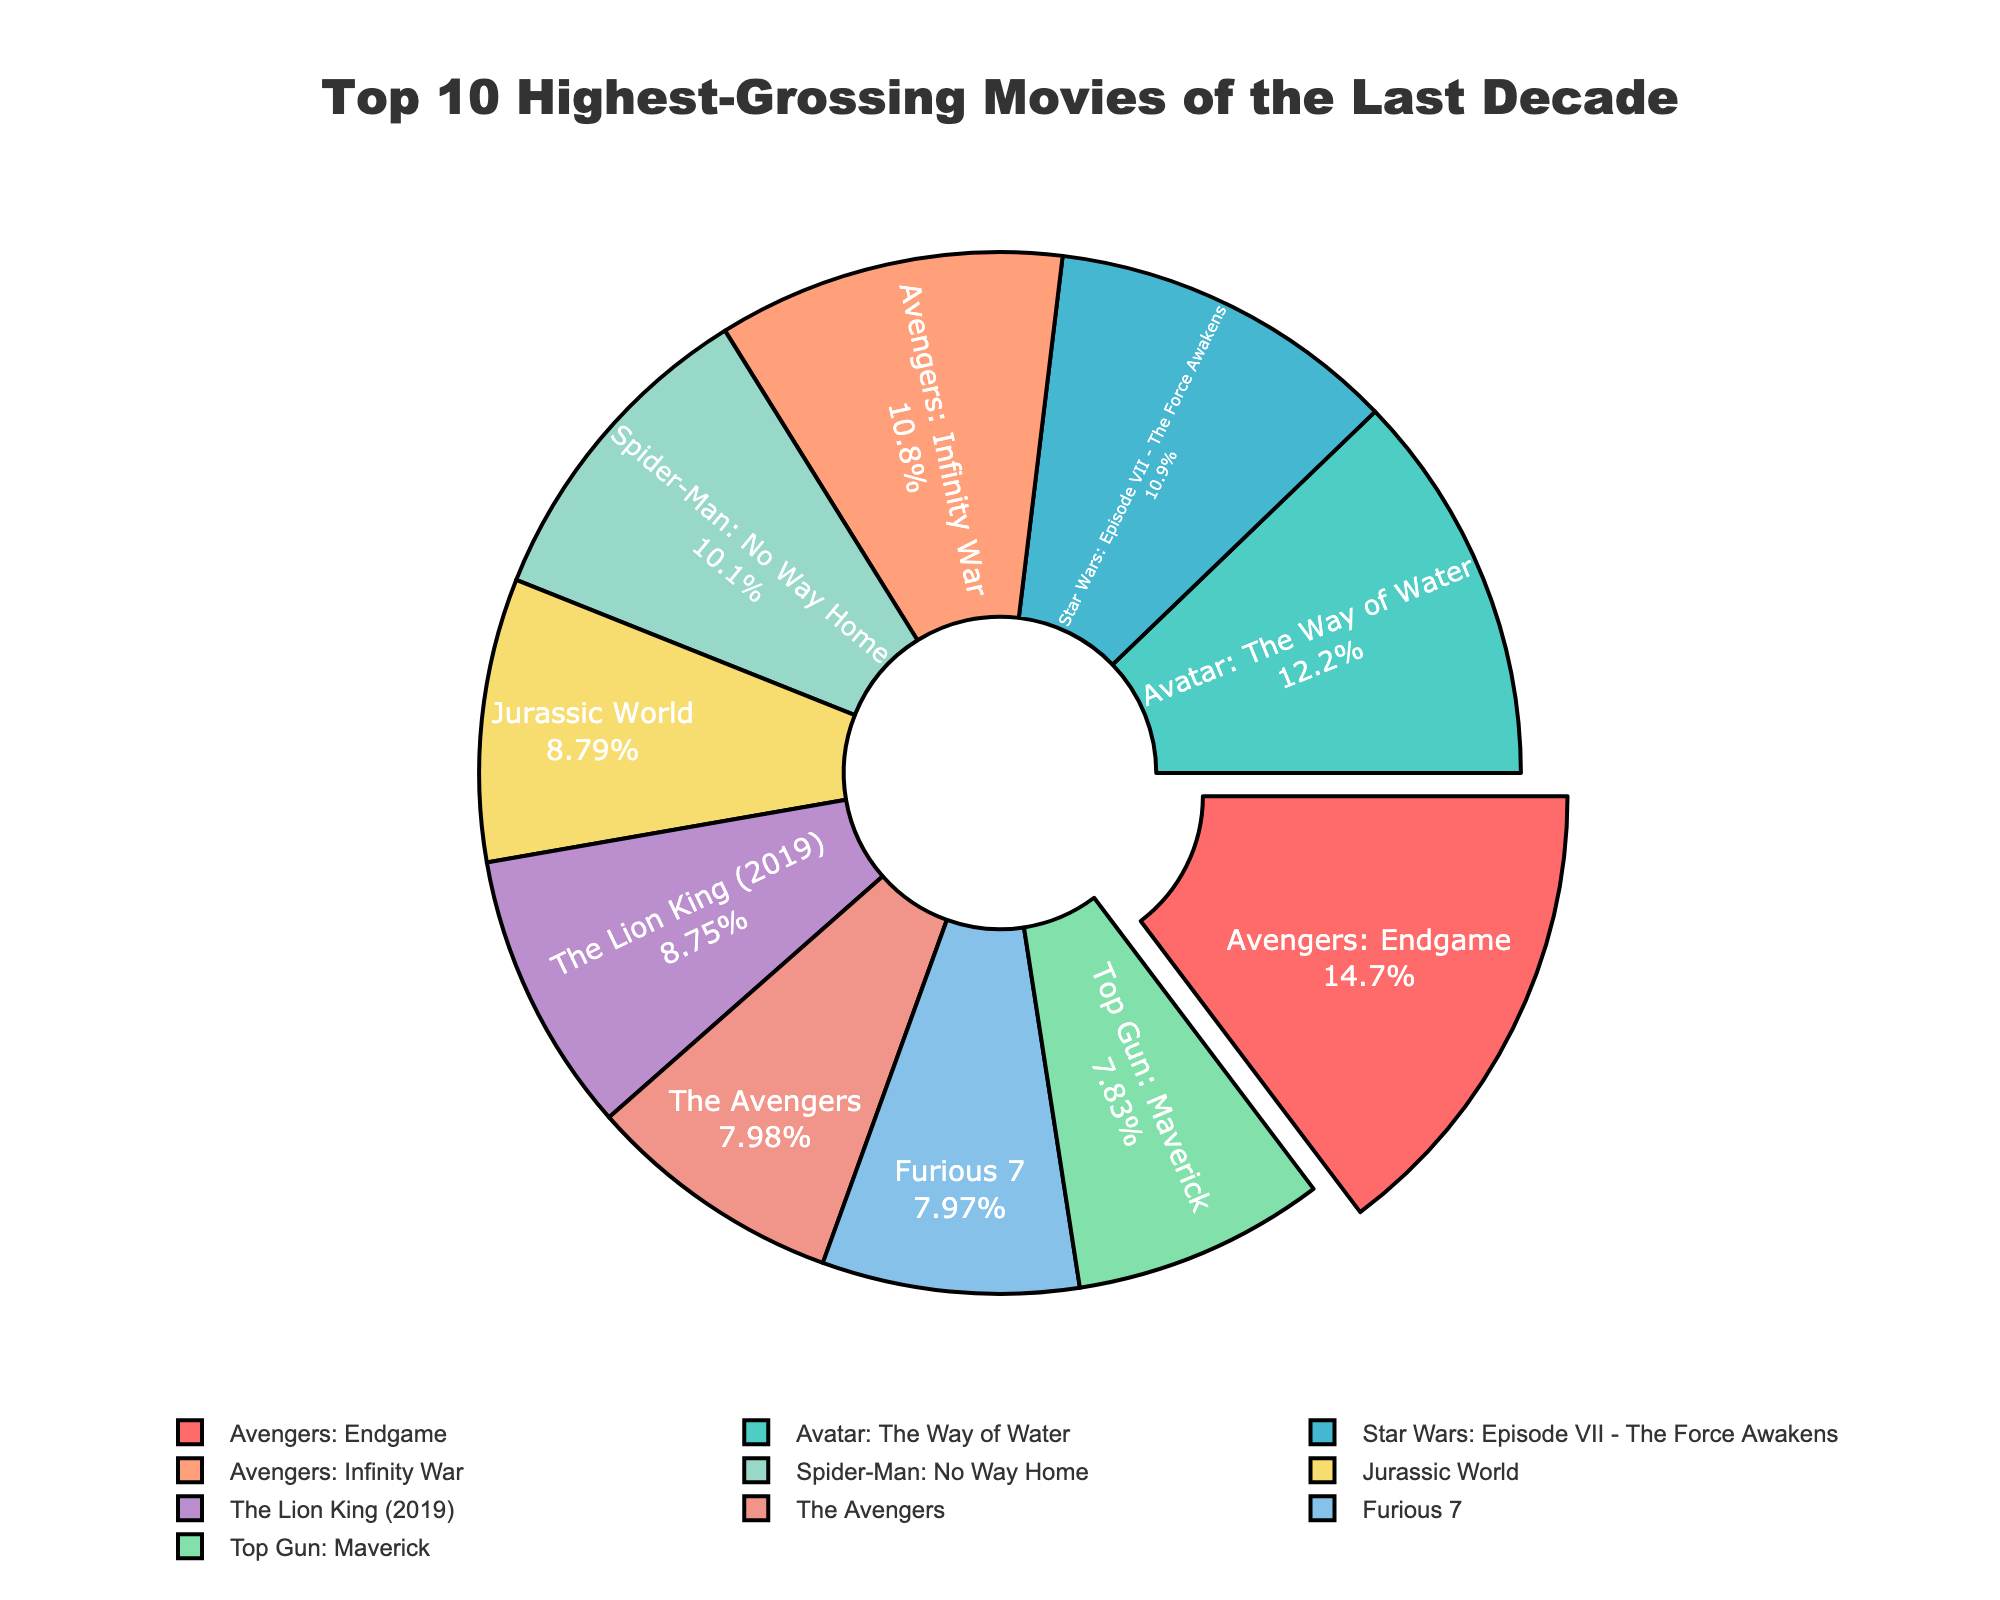Which movie had the highest box office revenue? The movie with the highest box office revenue will have the largest section in the pie chart. In this case, the largest section is labeled "Avengers: Endgame."
Answer: Avengers: Endgame Which movie earned more revenue, 'Furious 7' or 'Top Gun: Maverick'? Identify the sections representing 'Furious 7' and 'Top Gun: Maverick' and compare their size and percentage. 'Furious 7' and 'Top Gun: Maverick' have similar segment sizes, but 'Furious 7' has a slightly larger share.
Answer: Furious 7 What is the combined box office revenue of 'Avengers: Endgame' and 'Avatar: The Way of Water'? Find the values associated with these movies from the slices labeled accordingly, then add their revenues: 2.798 billion (Avengers: Endgame) + 2.32 billion (Avatar: The Way of Water) = 5.118 billion.
Answer: 5.118 billion What's the difference in revenue between 'Star Wars: Episode VII - The Force Awakens' and 'The Lion King (2019)'? Calculate the revenue difference: 2.068 billion (Star Wars: Episode VII - The Force Awakens) - 1.663 billion (The Lion King 2019) = 0.405 billion.
Answer: 0.405 billion Which movie segment is colored green? Identify the segment colored green visually; in the given color scheme, 'Jurassic World' is annotated with the green color.
Answer: Jurassic World How much more revenue did 'Avengers: Infinity War' make compared to 'The Avengers'? Subtract the revenues: 2.048 billion (Avengers: Infinity War) - 1.518 billion (The Avengers) = 0.53 billion.
Answer: 0.53 billion What percentage of the total box office revenue does 'Spider-Man: No Way Home' represent? The percentage is given directly in the pie chart's labels; 'Spider-Man: No Way Home' represents about 9%.
Answer: 9% Which movie has the smallest revenue share and what is it? The smallest segment in the pie chart will indicate the movie with the lowest revenue; 'Top Gun: Maverick' has the smallest share with 1.489 billion.
Answer: Top Gun: Maverick, 1.489 billion If you sum the revenues of 'The Lion King (2019)', 'The Avengers', and 'Jurassic World', what would the total be? Add the values: 1.663 billion (The Lion King 2019) + 1.518 billion (The Avengers) + 1.671 billion (Jurassic World) = 4.852 billion.
Answer: 4.852 billion 